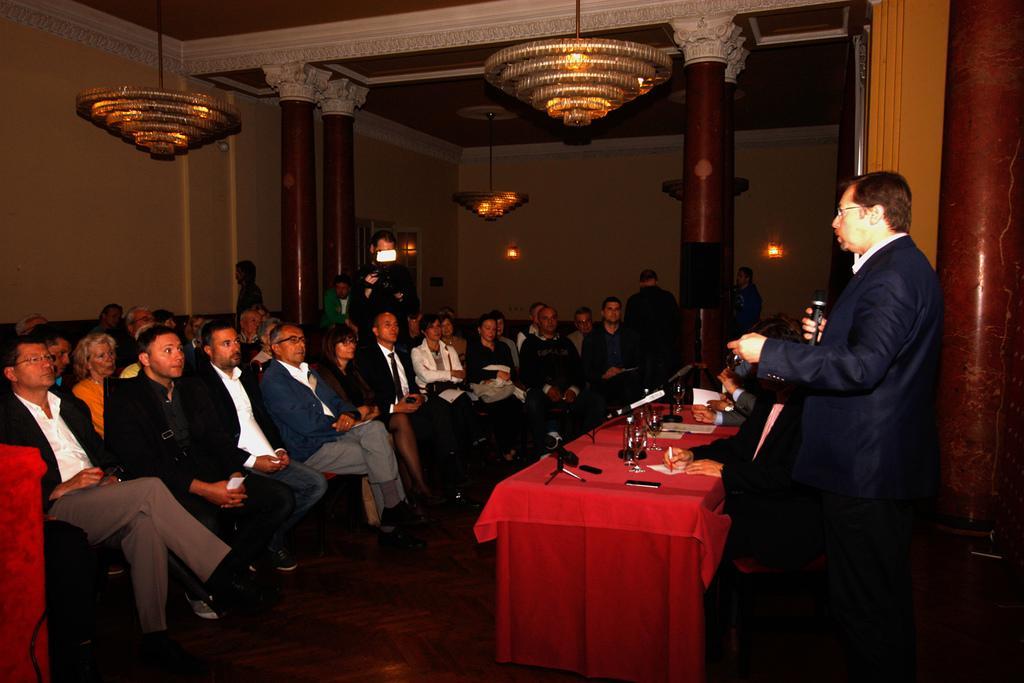Could you give a brief overview of what you see in this image? In this Image I see number of people in which most of them are sitting on chairs and few of them are standing. I can also see there is a table in front and there are few things on it and this man is holding a mic in his hand. In the background I see lights and this man is holding a camera. 